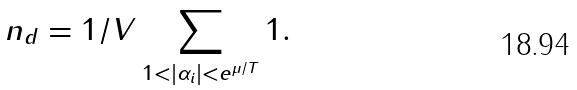Convert formula to latex. <formula><loc_0><loc_0><loc_500><loc_500>n _ { d } = 1 / V \sum _ { 1 < | \alpha _ { i } | < e ^ { \mu / T } } 1 .</formula> 